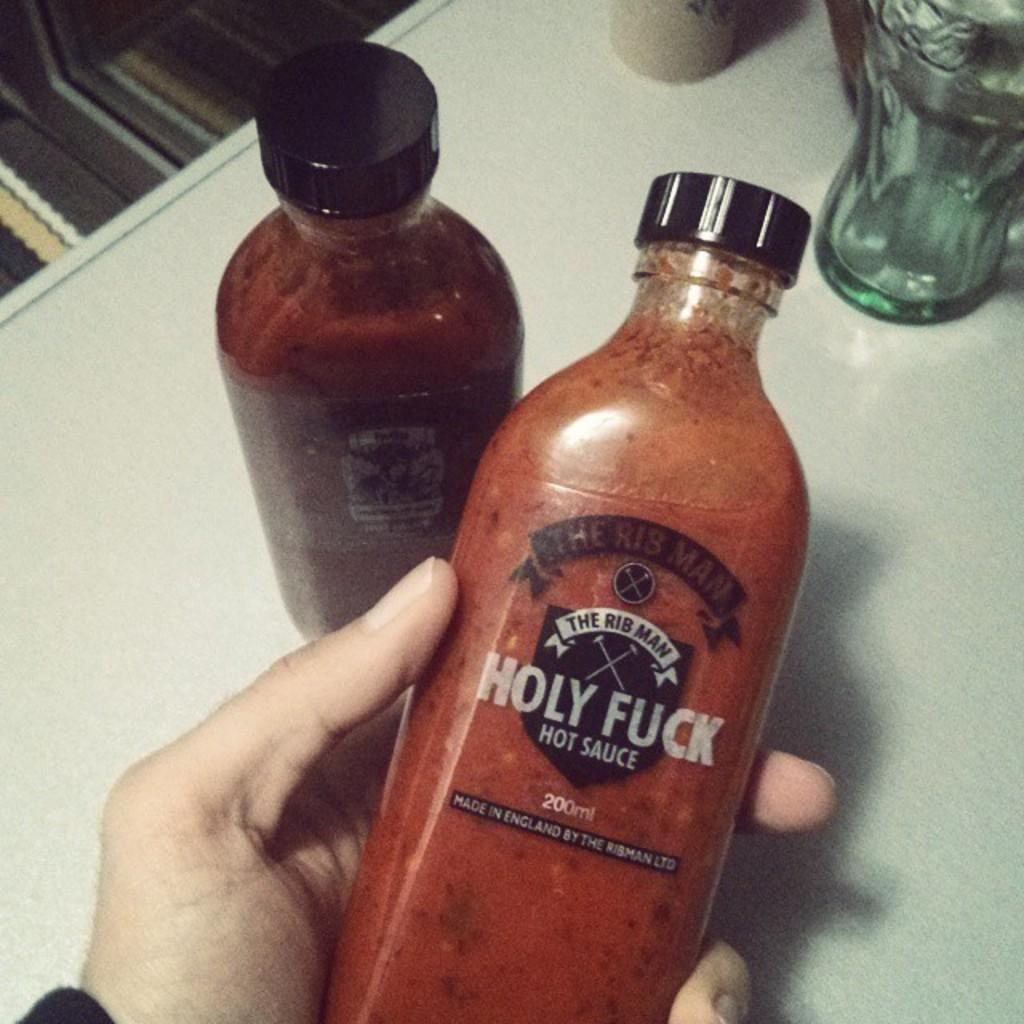Provide a one-sentence caption for the provided image. Two bottles one of which is in a hand that say Holy Fuck Hot Sauce. 